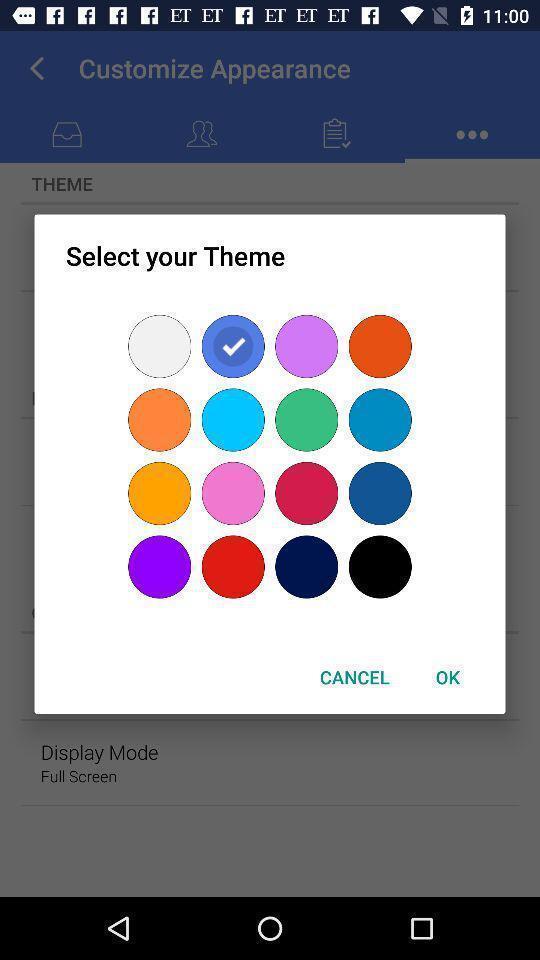Provide a detailed account of this screenshot. Popup of different colors to select in the application. 